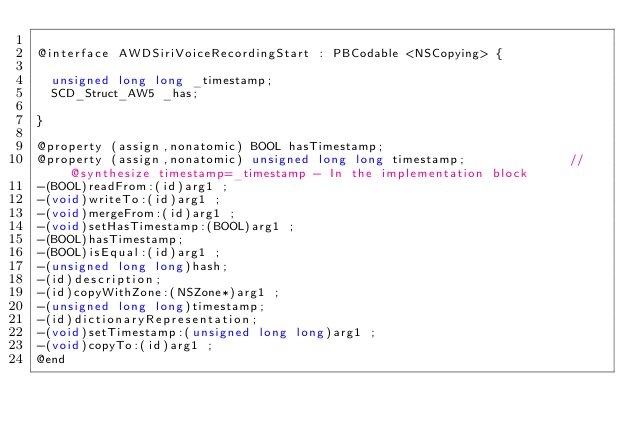<code> <loc_0><loc_0><loc_500><loc_500><_C_>
@interface AWDSiriVoiceRecordingStart : PBCodable <NSCopying> {

	unsigned long long _timestamp;
	SCD_Struct_AW5 _has;

}

@property (assign,nonatomic) BOOL hasTimestamp; 
@property (assign,nonatomic) unsigned long long timestamp;              //@synthesize timestamp=_timestamp - In the implementation block
-(BOOL)readFrom:(id)arg1 ;
-(void)writeTo:(id)arg1 ;
-(void)mergeFrom:(id)arg1 ;
-(void)setHasTimestamp:(BOOL)arg1 ;
-(BOOL)hasTimestamp;
-(BOOL)isEqual:(id)arg1 ;
-(unsigned long long)hash;
-(id)description;
-(id)copyWithZone:(NSZone*)arg1 ;
-(unsigned long long)timestamp;
-(id)dictionaryRepresentation;
-(void)setTimestamp:(unsigned long long)arg1 ;
-(void)copyTo:(id)arg1 ;
@end

</code> 